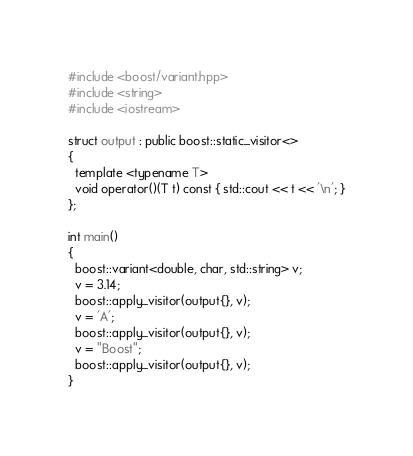Convert code to text. <code><loc_0><loc_0><loc_500><loc_500><_C++_>#include <boost/variant.hpp>
#include <string>
#include <iostream>

struct output : public boost::static_visitor<>
{
  template <typename T>
  void operator()(T t) const { std::cout << t << '\n'; }
};

int main()
{
  boost::variant<double, char, std::string> v;
  v = 3.14;
  boost::apply_visitor(output{}, v);
  v = 'A';
  boost::apply_visitor(output{}, v);
  v = "Boost";
  boost::apply_visitor(output{}, v);
}</code> 